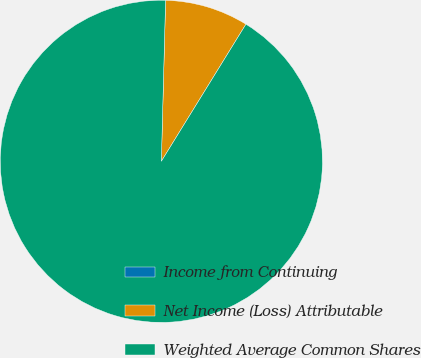Convert chart. <chart><loc_0><loc_0><loc_500><loc_500><pie_chart><fcel>Income from Continuing<fcel>Net Income (Loss) Attributable<fcel>Weighted Average Common Shares<nl><fcel>0.0%<fcel>8.38%<fcel>91.62%<nl></chart> 